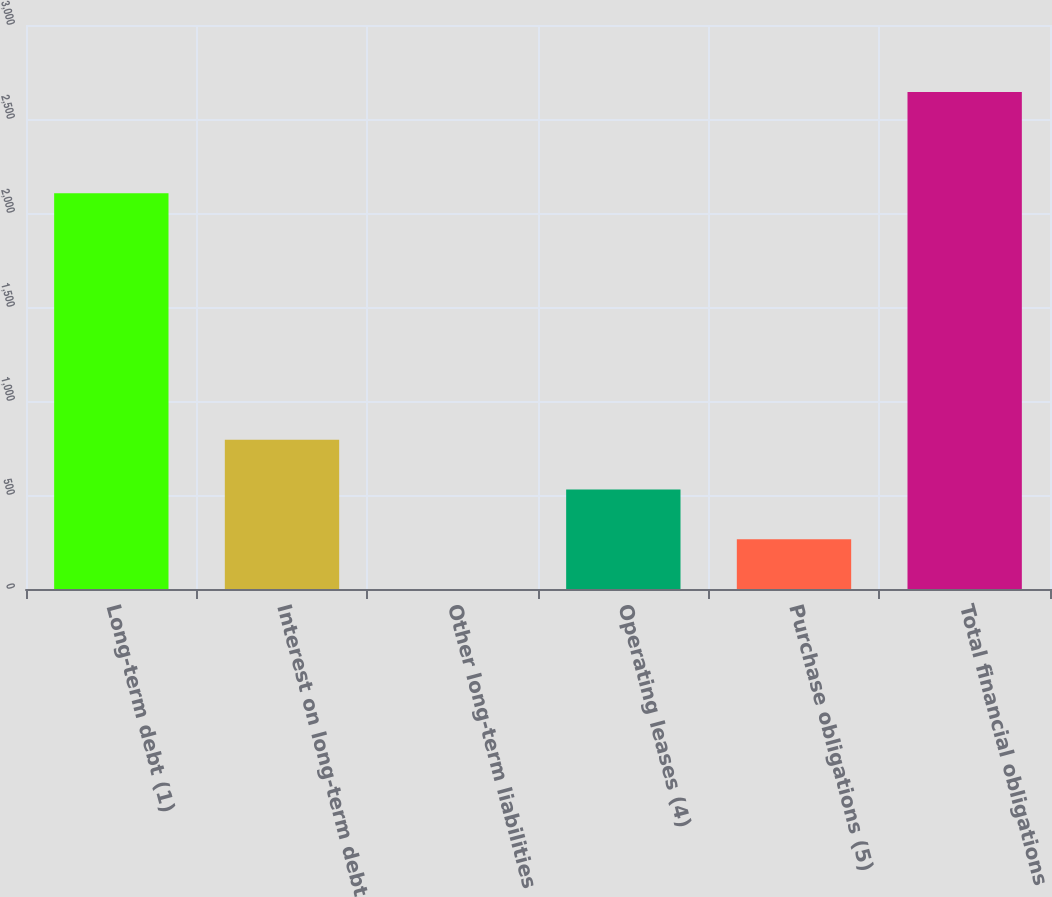<chart> <loc_0><loc_0><loc_500><loc_500><bar_chart><fcel>Long-term debt (1)<fcel>Interest on long-term debt<fcel>Other long-term liabilities<fcel>Operating leases (4)<fcel>Purchase obligations (5)<fcel>Total financial obligations<nl><fcel>2105.4<fcel>793.33<fcel>0.4<fcel>529.02<fcel>264.71<fcel>2643.5<nl></chart> 